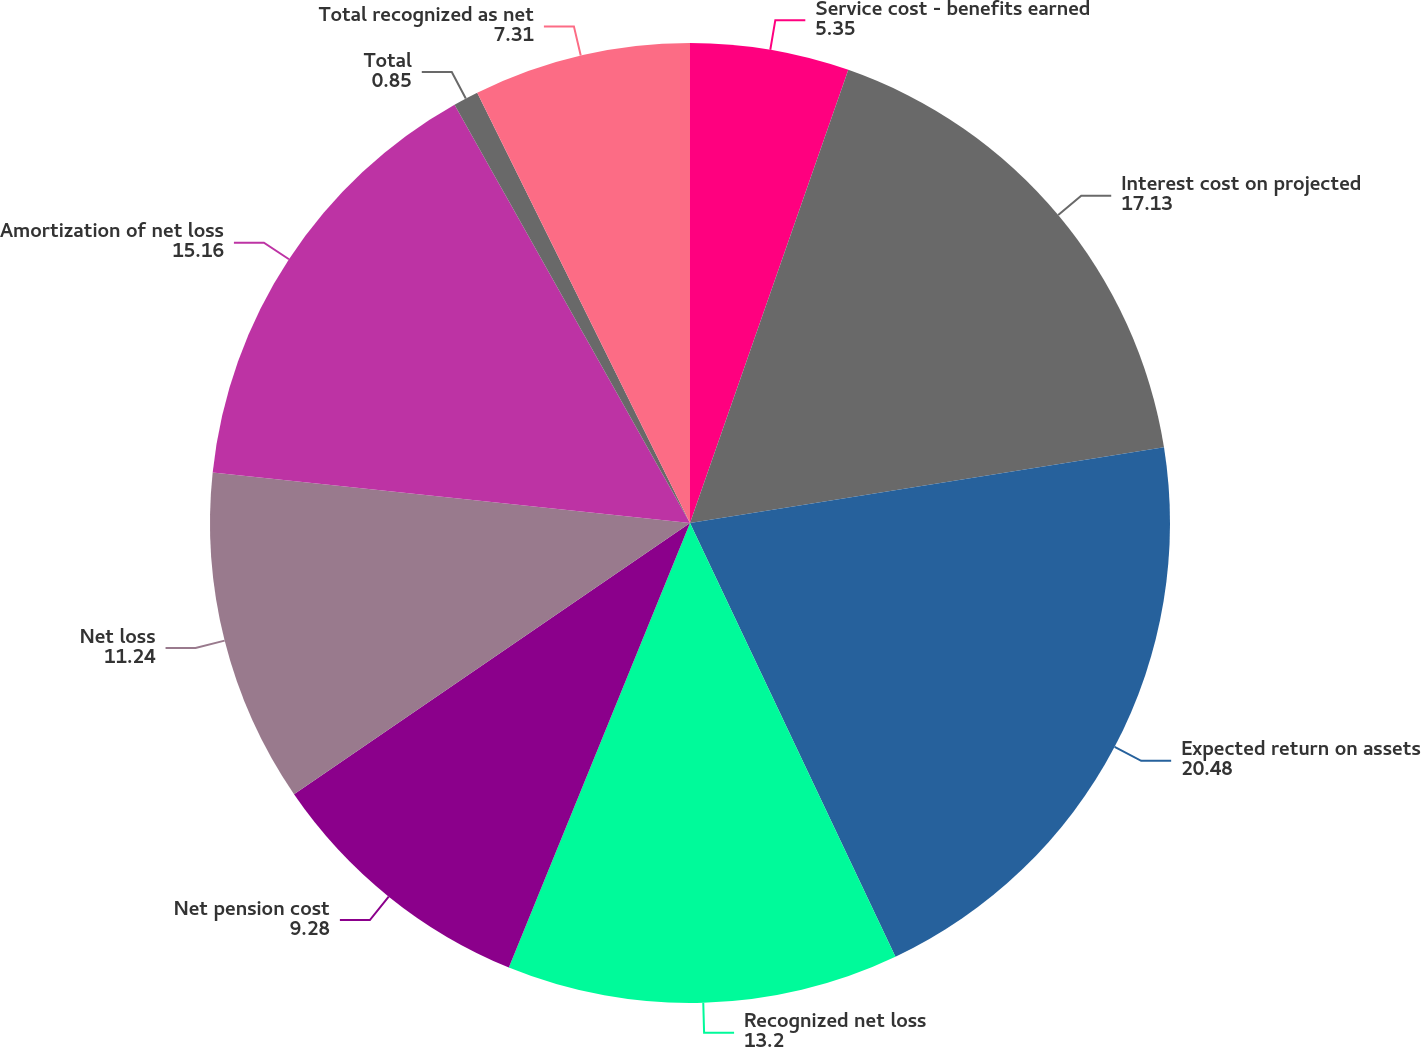Convert chart to OTSL. <chart><loc_0><loc_0><loc_500><loc_500><pie_chart><fcel>Service cost - benefits earned<fcel>Interest cost on projected<fcel>Expected return on assets<fcel>Recognized net loss<fcel>Net pension cost<fcel>Net loss<fcel>Amortization of net loss<fcel>Total<fcel>Total recognized as net<nl><fcel>5.35%<fcel>17.13%<fcel>20.48%<fcel>13.2%<fcel>9.28%<fcel>11.24%<fcel>15.16%<fcel>0.85%<fcel>7.31%<nl></chart> 